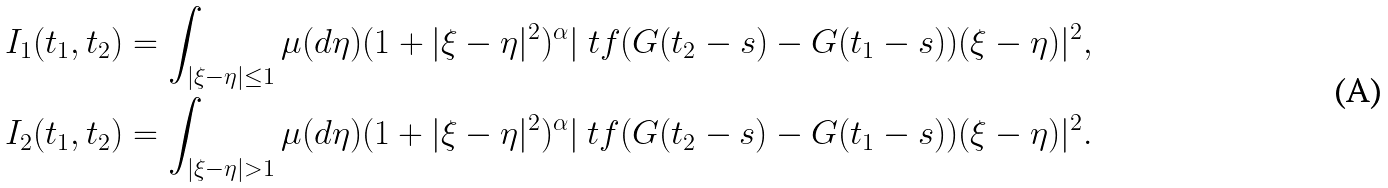Convert formula to latex. <formula><loc_0><loc_0><loc_500><loc_500>I _ { 1 } ( t _ { 1 } , t _ { 2 } ) & = \int _ { | \xi - \eta | \leq 1 } \mu ( d \eta ) ( 1 + | \xi - \eta | ^ { 2 } ) ^ { \alpha } | \ t f ( G ( t _ { 2 } - s ) - G ( t _ { 1 } - s ) ) ( \xi - \eta ) | ^ { 2 } , \\ I _ { 2 } ( t _ { 1 } , t _ { 2 } ) & = \int _ { | \xi - \eta | > 1 } \mu ( d \eta ) ( 1 + | \xi - \eta | ^ { 2 } ) ^ { \alpha } | \ t f ( G ( t _ { 2 } - s ) - G ( t _ { 1 } - s ) ) ( \xi - \eta ) | ^ { 2 } .</formula> 